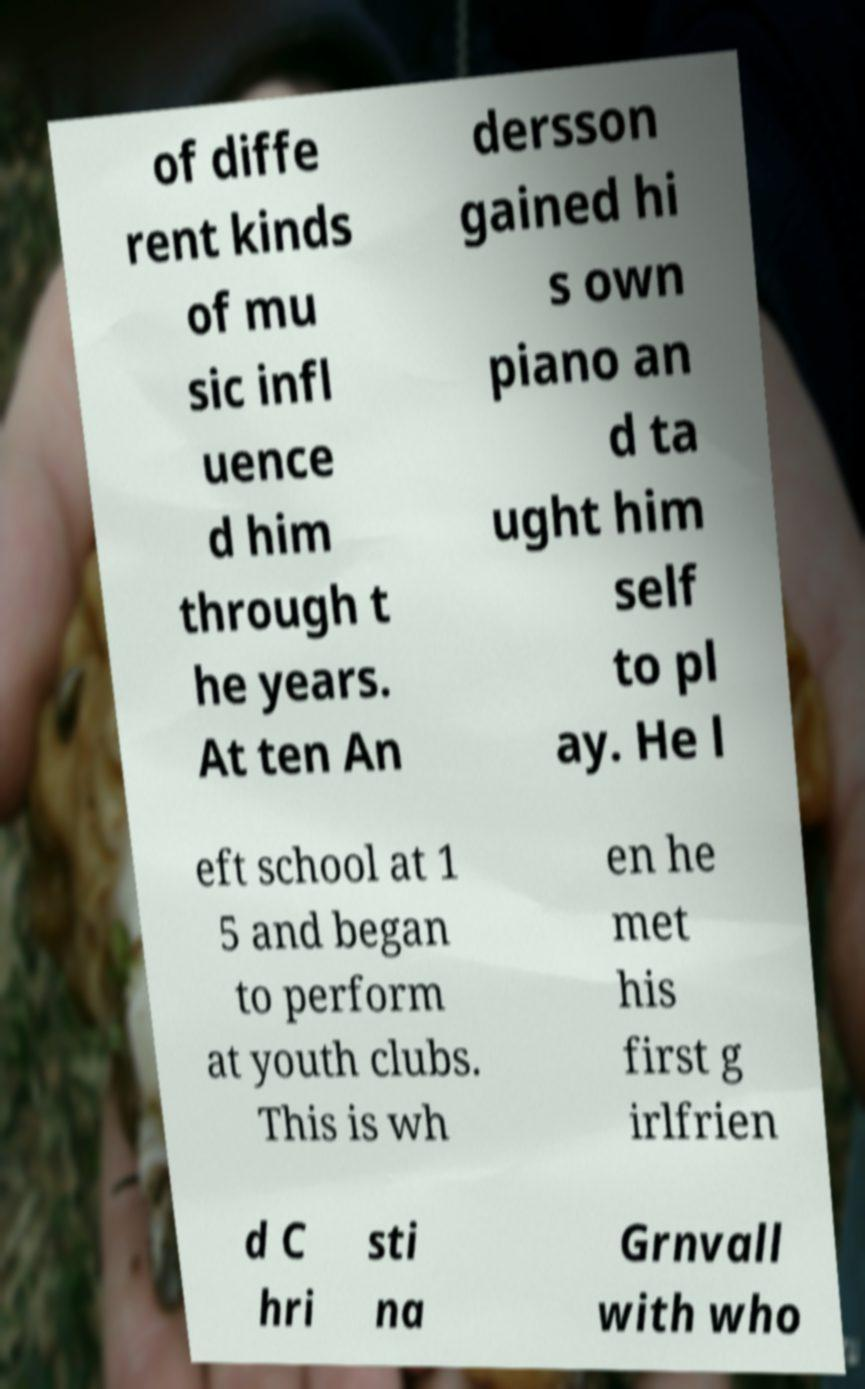Could you extract and type out the text from this image? of diffe rent kinds of mu sic infl uence d him through t he years. At ten An dersson gained hi s own piano an d ta ught him self to pl ay. He l eft school at 1 5 and began to perform at youth clubs. This is wh en he met his first g irlfrien d C hri sti na Grnvall with who 